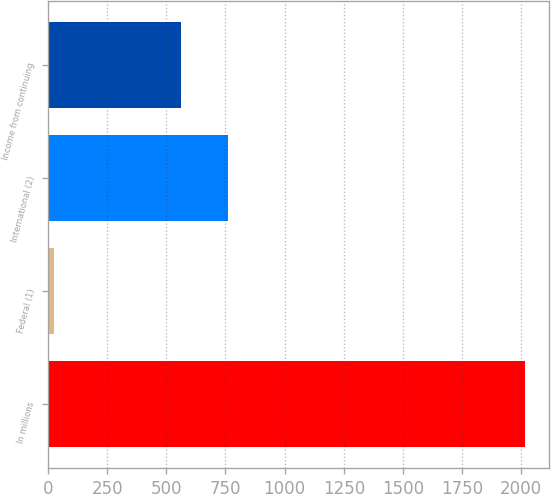<chart> <loc_0><loc_0><loc_500><loc_500><bar_chart><fcel>In millions<fcel>Federal (1)<fcel>International (2)<fcel>Income from continuing<nl><fcel>2016<fcel>25.6<fcel>760.04<fcel>561<nl></chart> 